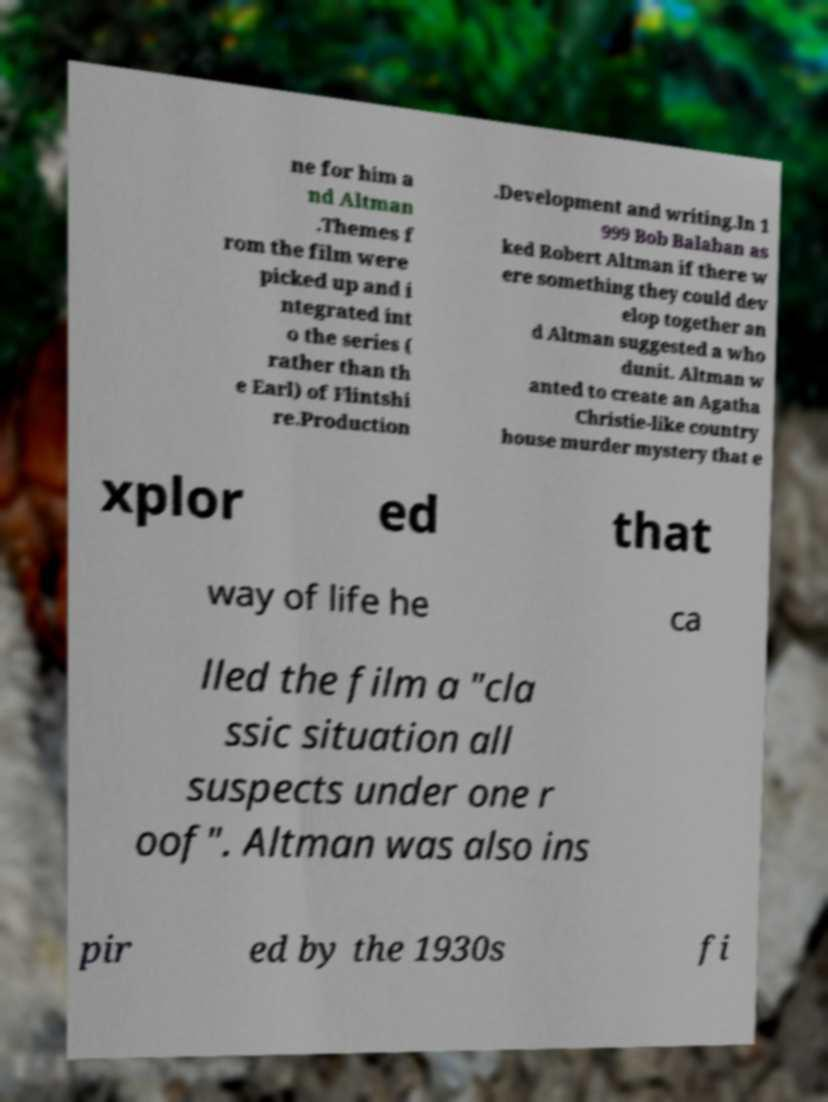For documentation purposes, I need the text within this image transcribed. Could you provide that? ne for him a nd Altman .Themes f rom the film were picked up and i ntegrated int o the series ( rather than th e Earl) of Flintshi re.Production .Development and writing.In 1 999 Bob Balaban as ked Robert Altman if there w ere something they could dev elop together an d Altman suggested a who dunit. Altman w anted to create an Agatha Christie-like country house murder mystery that e xplor ed that way of life he ca lled the film a "cla ssic situation all suspects under one r oof". Altman was also ins pir ed by the 1930s fi 